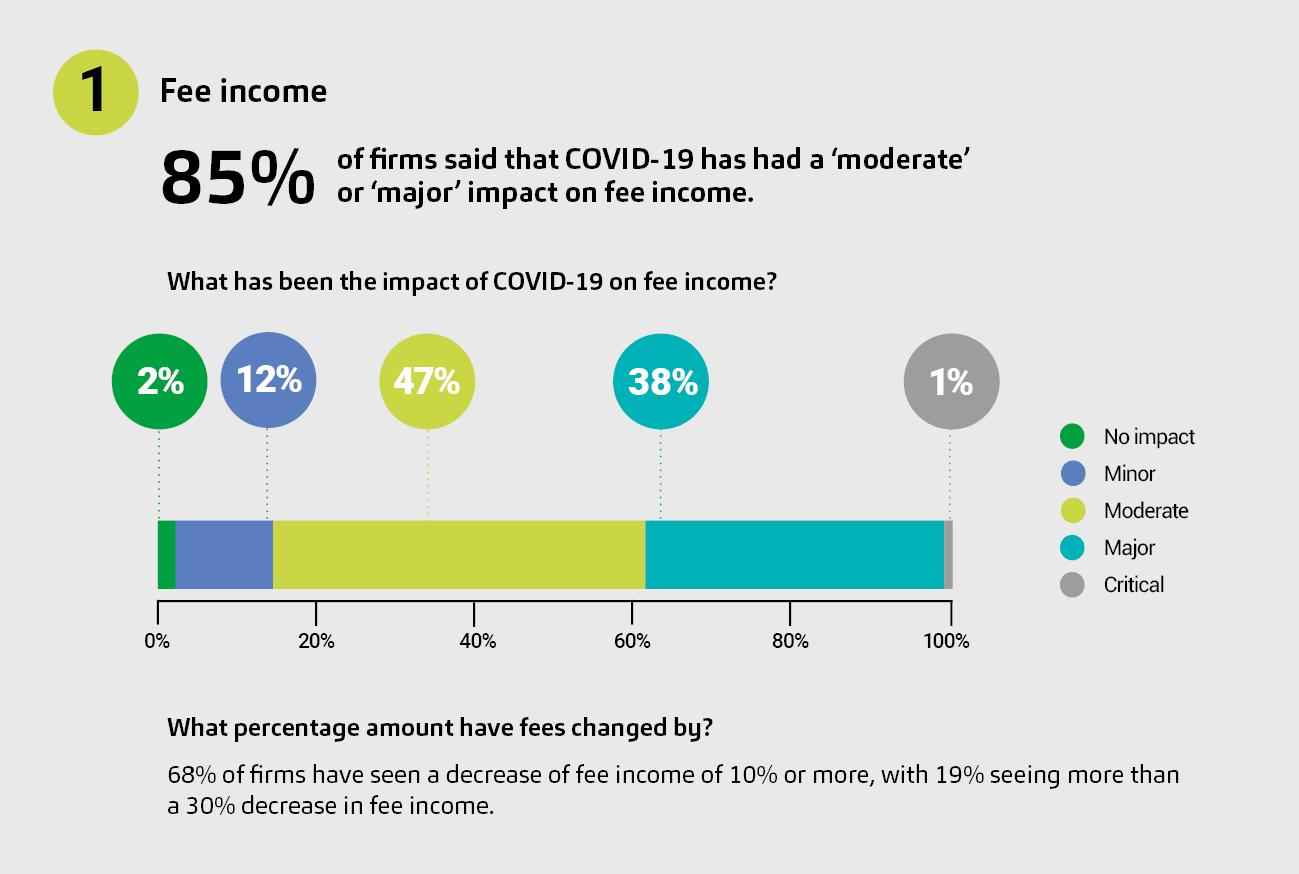Point out several critical features in this image. According to the information provided, 14% of firms had no impact or minor impact on their fee income due to COVID-19. According to the data, only 2% of firms reported that the COVID-19 pandemic had no impact on their business. According to our survey, COVID-19 had a moderate impact on 47% of firms. The study found that firms having a "major impact" were higher by 37% than those having a "critical impact. The color used to indicate 'no impact' is green. 